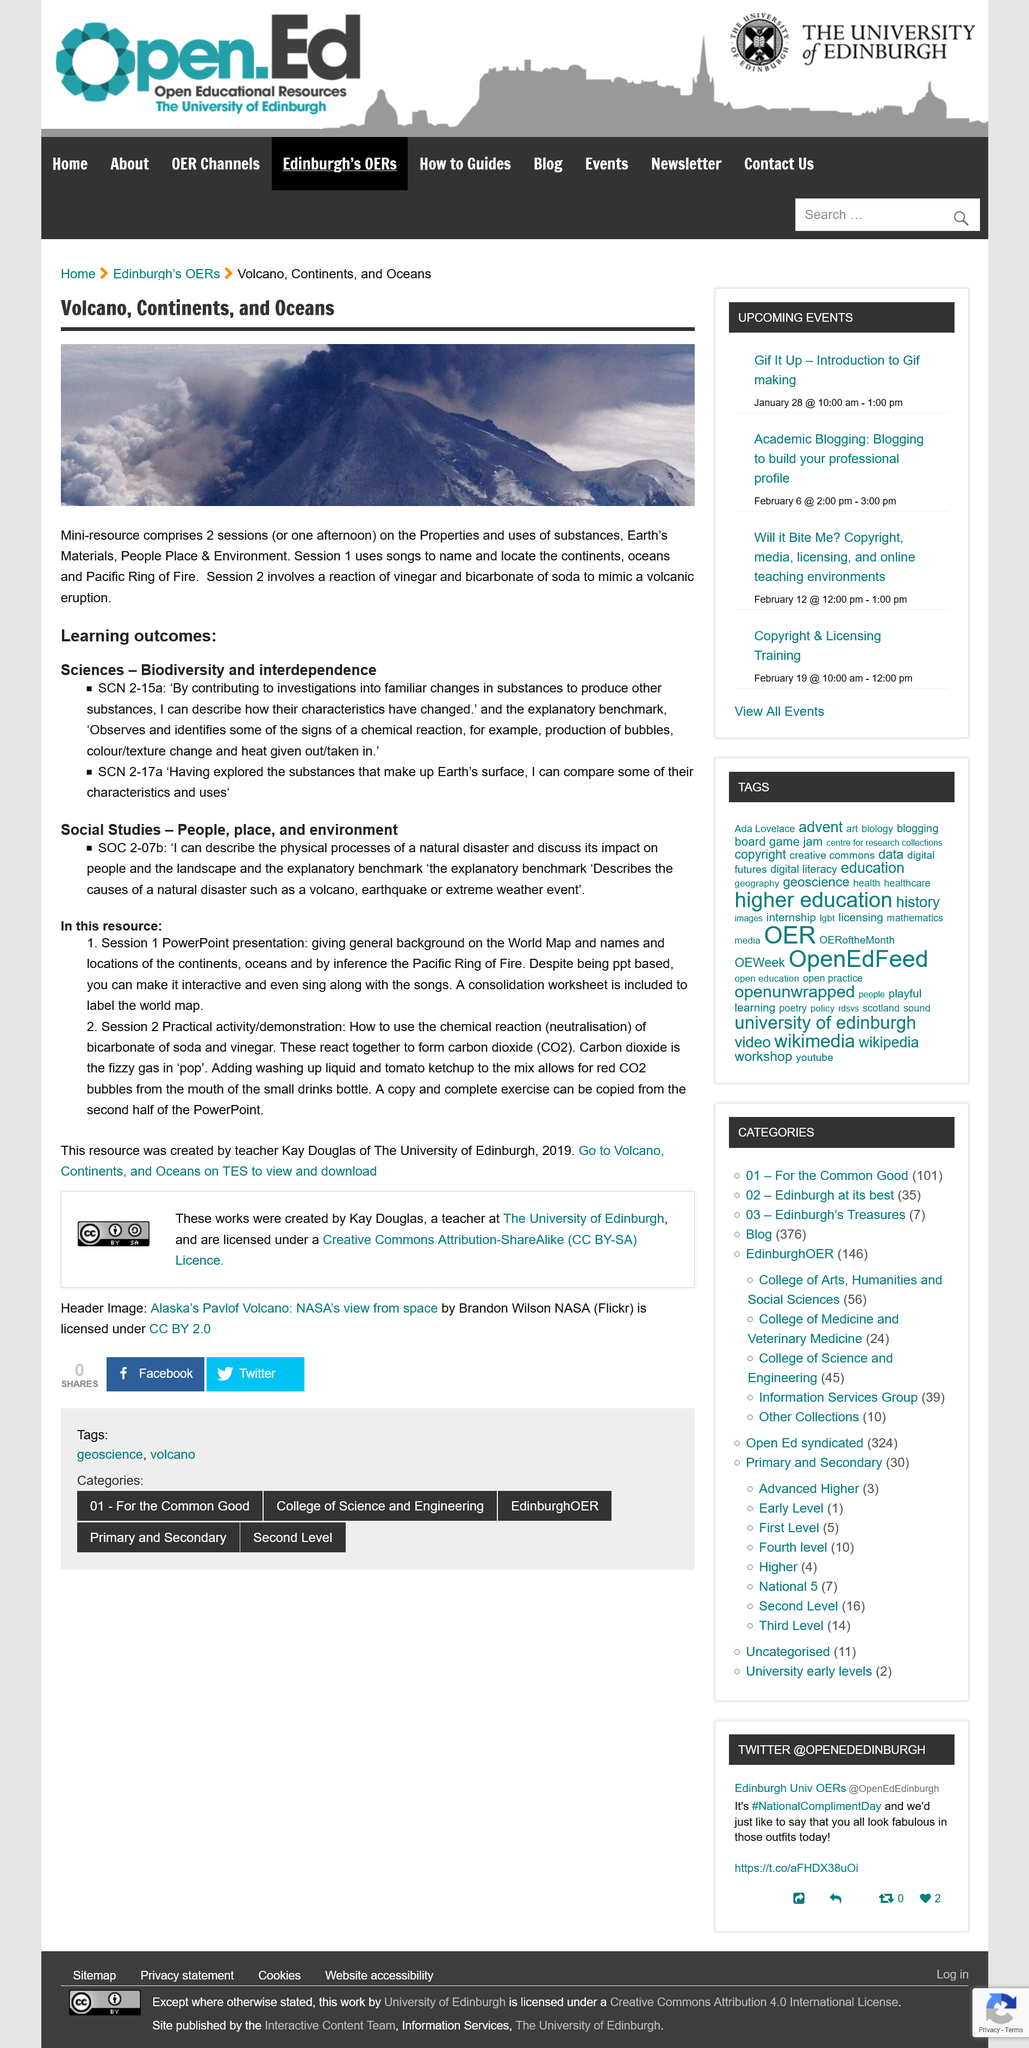Specify some key components in this picture. It is possible to obtain the resource from Volcano, Continents and Oceans section on TES. Kay Douglas of the University of Edinburgh created the Social Studies - People, place and environment resource. There are two sessions included in the Social Studies - People, place and environment resource. This document contains two learning outcomes. This is a Science resource that is focused on the subjects of Biodiversity and Interdependence. 